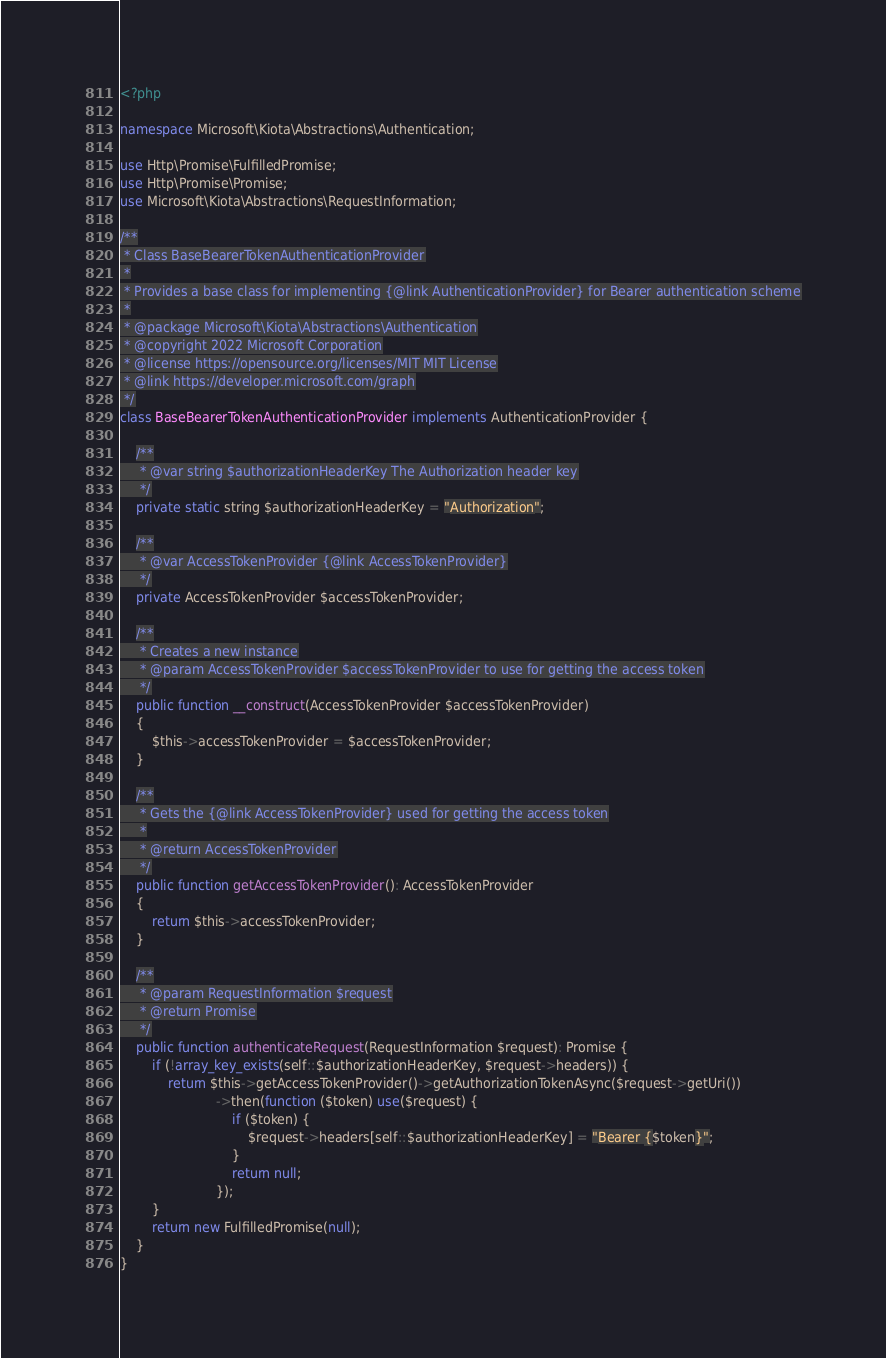Convert code to text. <code><loc_0><loc_0><loc_500><loc_500><_PHP_><?php

namespace Microsoft\Kiota\Abstractions\Authentication;

use Http\Promise\FulfilledPromise;
use Http\Promise\Promise;
use Microsoft\Kiota\Abstractions\RequestInformation;

/**
 * Class BaseBearerTokenAuthenticationProvider
 *
 * Provides a base class for implementing {@link AuthenticationProvider} for Bearer authentication scheme
 *
 * @package Microsoft\Kiota\Abstractions\Authentication
 * @copyright 2022 Microsoft Corporation
 * @license https://opensource.org/licenses/MIT MIT License
 * @link https://developer.microsoft.com/graph
 */
class BaseBearerTokenAuthenticationProvider implements AuthenticationProvider {

    /**
     * @var string $authorizationHeaderKey The Authorization header key
     */
    private static string $authorizationHeaderKey = "Authorization";

    /**
     * @var AccessTokenProvider {@link AccessTokenProvider}
     */
    private AccessTokenProvider $accessTokenProvider;

    /**
     * Creates a new instance
     * @param AccessTokenProvider $accessTokenProvider to use for getting the access token
     */
    public function __construct(AccessTokenProvider $accessTokenProvider)
    {
        $this->accessTokenProvider = $accessTokenProvider;
    }

    /**
     * Gets the {@link AccessTokenProvider} used for getting the access token
     *
     * @return AccessTokenProvider
     */
    public function getAccessTokenProvider(): AccessTokenProvider
    {
        return $this->accessTokenProvider;
    }

    /**
     * @param RequestInformation $request
     * @return Promise
     */
    public function authenticateRequest(RequestInformation $request): Promise {
        if (!array_key_exists(self::$authorizationHeaderKey, $request->headers)) {
            return $this->getAccessTokenProvider()->getAuthorizationTokenAsync($request->getUri())
                        ->then(function ($token) use($request) {
                            if ($token) {
                                $request->headers[self::$authorizationHeaderKey] = "Bearer {$token}";
                            }
                            return null;
                        });
        }
        return new FulfilledPromise(null);
    }
}
</code> 